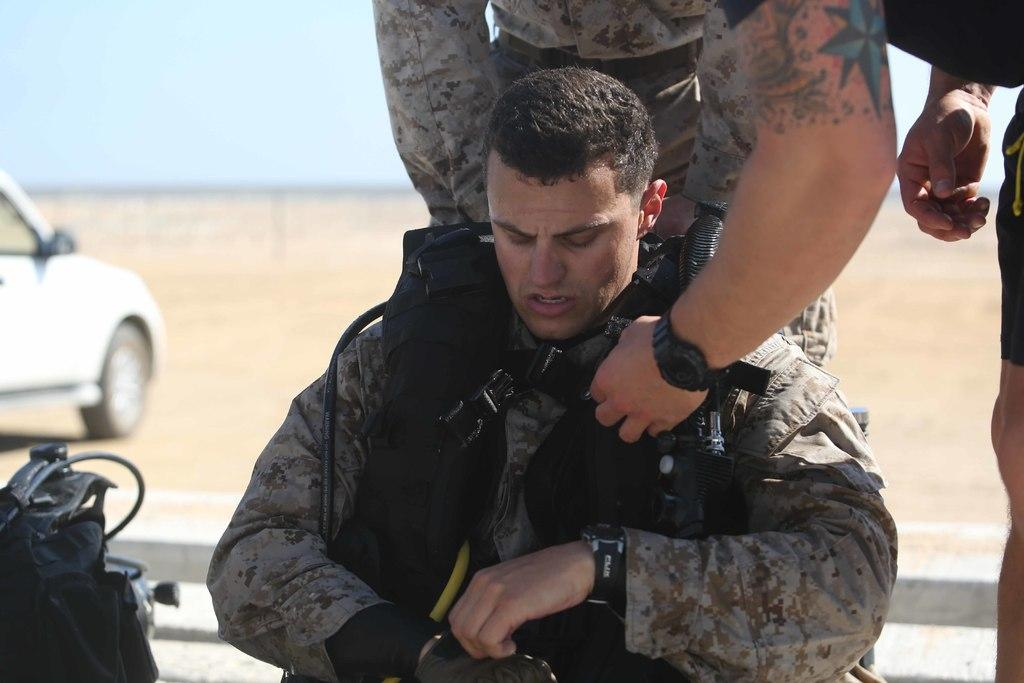What are the persons in the image wearing? The persons in the image are wearing uniforms. What type of surface is visible in the image? There is ground visible in the image. What is located on the ground in the image? There is a vehicle on the ground in the image. What part of the natural environment is visible in the image? The sky is visible in the image. How many trees can be seen in the image? There are no trees visible in the image. What type of butter is being used in the competition depicted in the image? There is no competition or butter present in the image. 